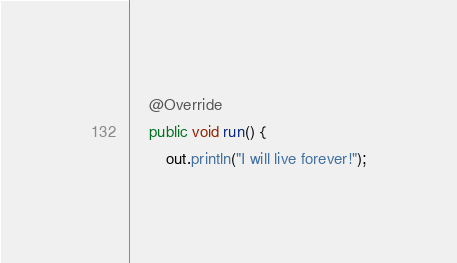Convert code to text. <code><loc_0><loc_0><loc_500><loc_500><_Java_>
	@Override
	public void run() {
		out.println("I will live forever!");</code> 